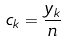Convert formula to latex. <formula><loc_0><loc_0><loc_500><loc_500>c _ { k } = \frac { y _ { k } } { n }</formula> 